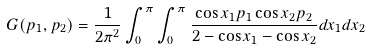Convert formula to latex. <formula><loc_0><loc_0><loc_500><loc_500>G ( p _ { 1 } , p _ { 2 } ) = \frac { 1 } { 2 \pi ^ { 2 } } \int _ { 0 } ^ { \pi } \int _ { 0 } ^ { \pi } \frac { \cos x _ { 1 } p _ { 1 } \cos x _ { 2 } p _ { 2 } } { 2 - \cos x _ { 1 } - \cos x _ { 2 } } d x _ { 1 } d x _ { 2 }</formula> 